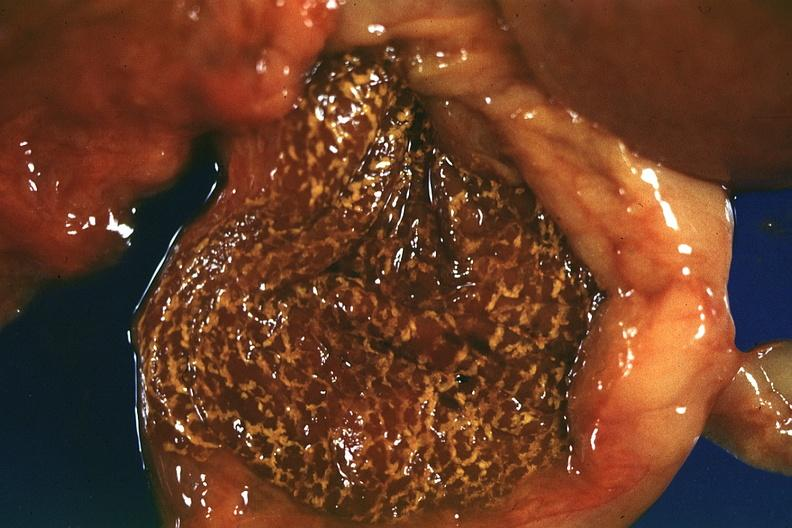does this image show fresh tissue but rather autolyzed appearance?
Answer the question using a single word or phrase. Yes 